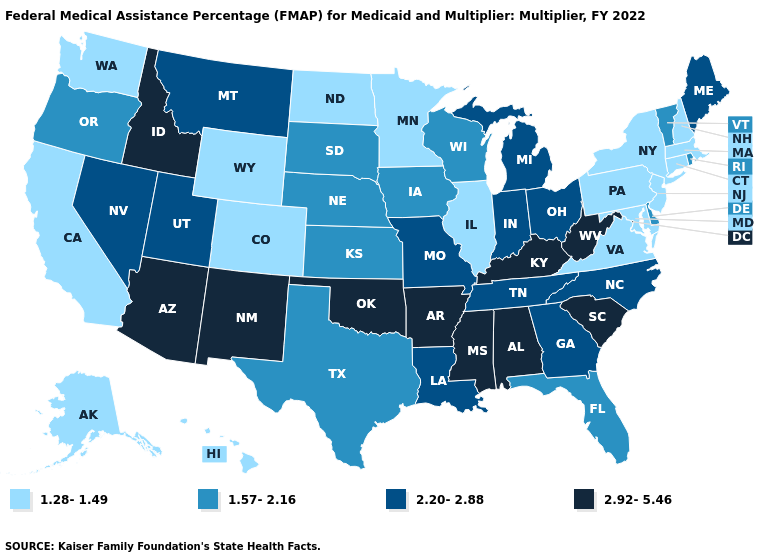Does the map have missing data?
Concise answer only. No. What is the value of Missouri?
Be succinct. 2.20-2.88. Name the states that have a value in the range 2.92-5.46?
Concise answer only. Alabama, Arizona, Arkansas, Idaho, Kentucky, Mississippi, New Mexico, Oklahoma, South Carolina, West Virginia. What is the lowest value in the MidWest?
Concise answer only. 1.28-1.49. What is the lowest value in the USA?
Write a very short answer. 1.28-1.49. Is the legend a continuous bar?
Answer briefly. No. What is the value of Mississippi?
Short answer required. 2.92-5.46. Name the states that have a value in the range 2.20-2.88?
Answer briefly. Georgia, Indiana, Louisiana, Maine, Michigan, Missouri, Montana, Nevada, North Carolina, Ohio, Tennessee, Utah. Name the states that have a value in the range 1.57-2.16?
Write a very short answer. Delaware, Florida, Iowa, Kansas, Nebraska, Oregon, Rhode Island, South Dakota, Texas, Vermont, Wisconsin. Name the states that have a value in the range 2.20-2.88?
Short answer required. Georgia, Indiana, Louisiana, Maine, Michigan, Missouri, Montana, Nevada, North Carolina, Ohio, Tennessee, Utah. Does the map have missing data?
Answer briefly. No. Name the states that have a value in the range 1.57-2.16?
Write a very short answer. Delaware, Florida, Iowa, Kansas, Nebraska, Oregon, Rhode Island, South Dakota, Texas, Vermont, Wisconsin. What is the value of New Jersey?
Answer briefly. 1.28-1.49. Among the states that border Maryland , which have the lowest value?
Quick response, please. Pennsylvania, Virginia. 